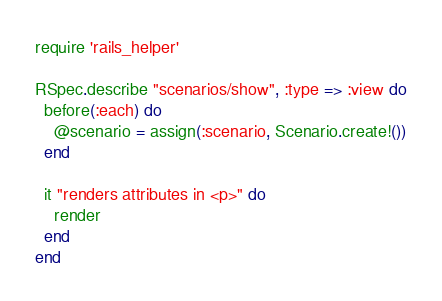Convert code to text. <code><loc_0><loc_0><loc_500><loc_500><_Ruby_>require 'rails_helper'

RSpec.describe "scenarios/show", :type => :view do
  before(:each) do
    @scenario = assign(:scenario, Scenario.create!())
  end

  it "renders attributes in <p>" do
    render
  end
end
</code> 